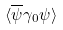<formula> <loc_0><loc_0><loc_500><loc_500>\langle \overline { \psi } \gamma _ { 0 } \psi \rangle</formula> 